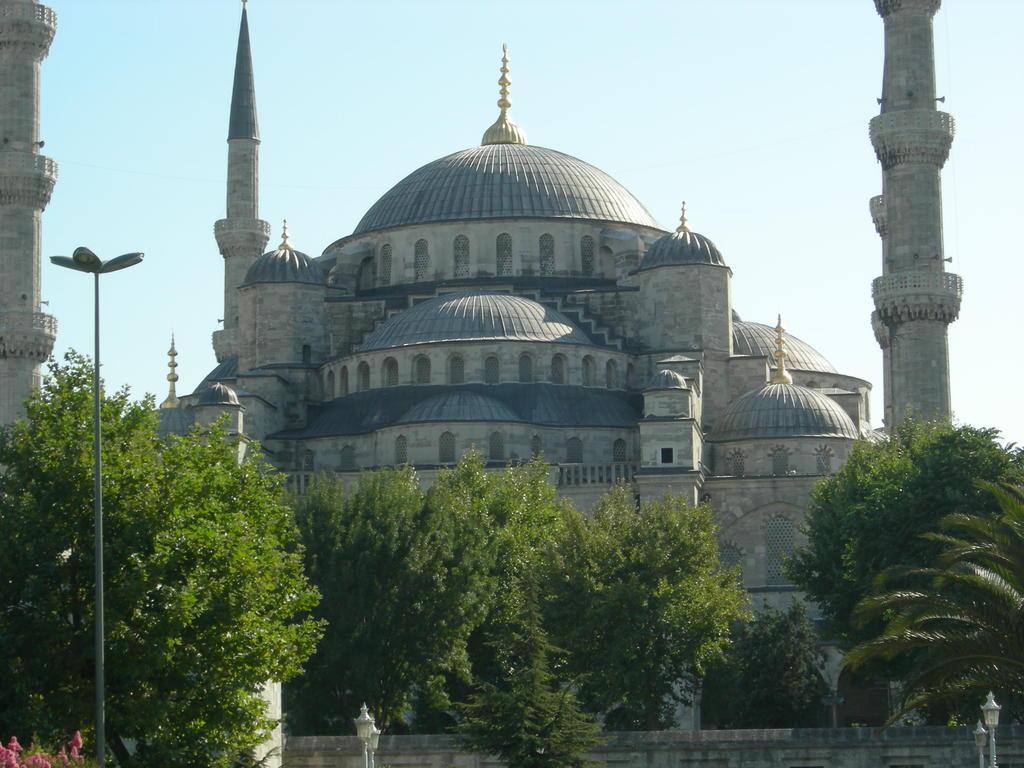Describe this image in one or two sentences. In the center of the image we can see a building. At the bottom of the image we can see the trees, electric light poles, wall, flowers. At the top of the image we can see the sky. 